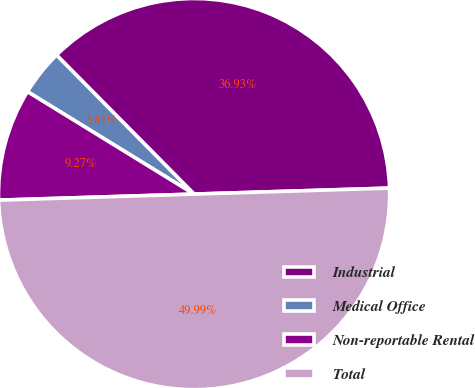Convert chart. <chart><loc_0><loc_0><loc_500><loc_500><pie_chart><fcel>Industrial<fcel>Medical Office<fcel>Non-reportable Rental<fcel>Total<nl><fcel>36.93%<fcel>3.81%<fcel>9.27%<fcel>50.0%<nl></chart> 